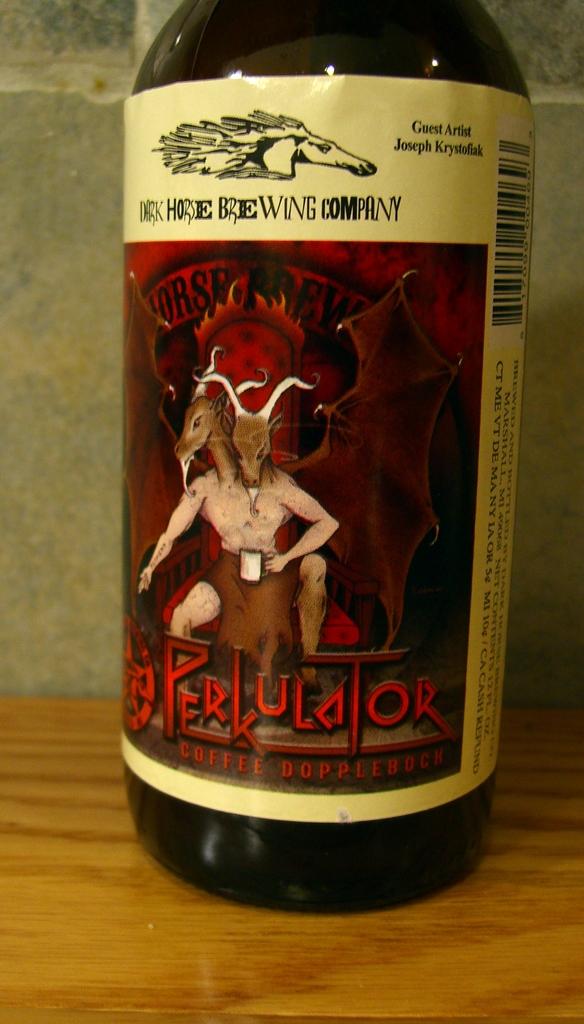Is this a coffee?
Provide a succinct answer. Yes. What is the name of the brewing company>?
Make the answer very short. Dark horse. 